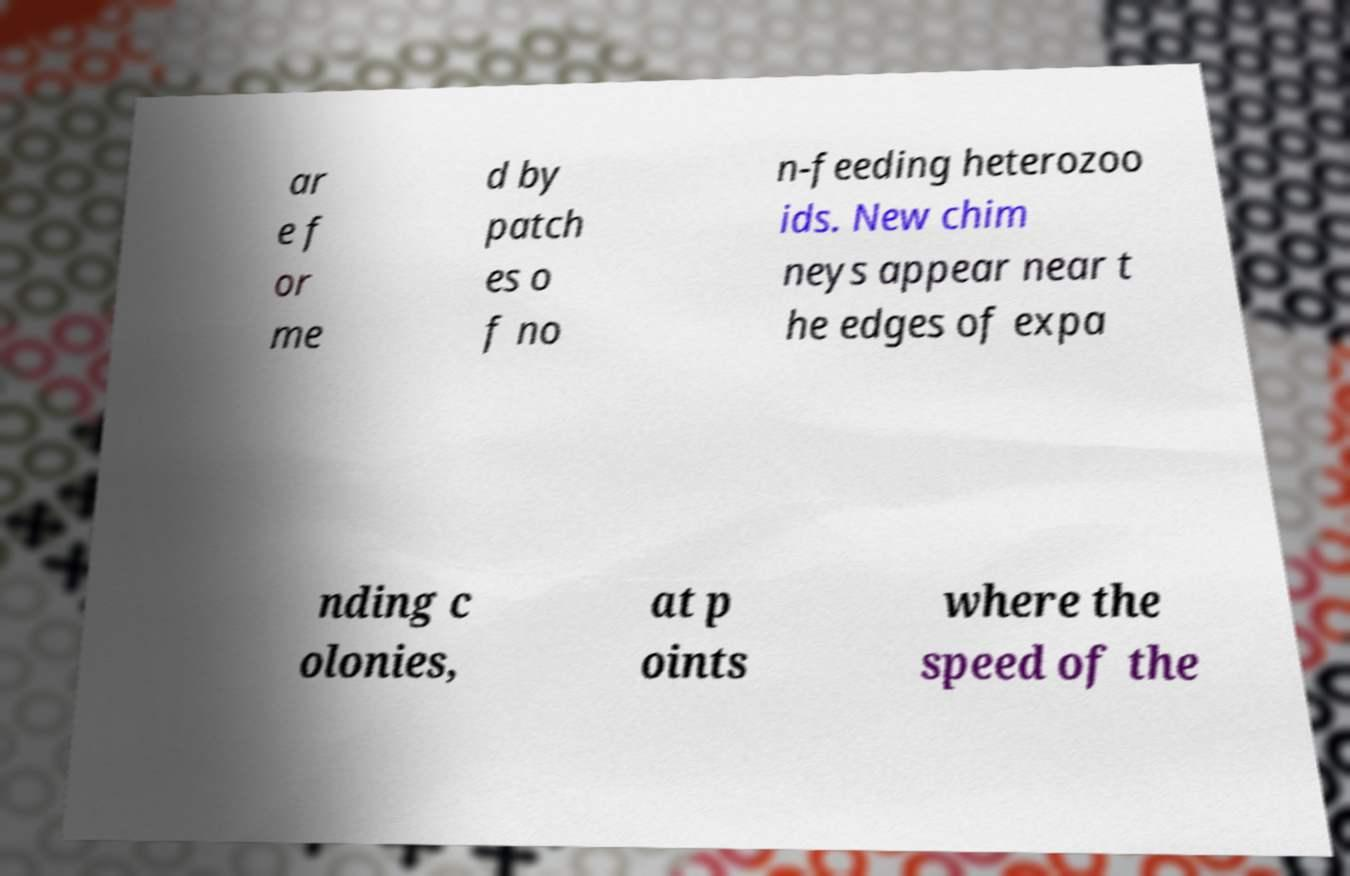What messages or text are displayed in this image? I need them in a readable, typed format. ar e f or me d by patch es o f no n-feeding heterozoo ids. New chim neys appear near t he edges of expa nding c olonies, at p oints where the speed of the 